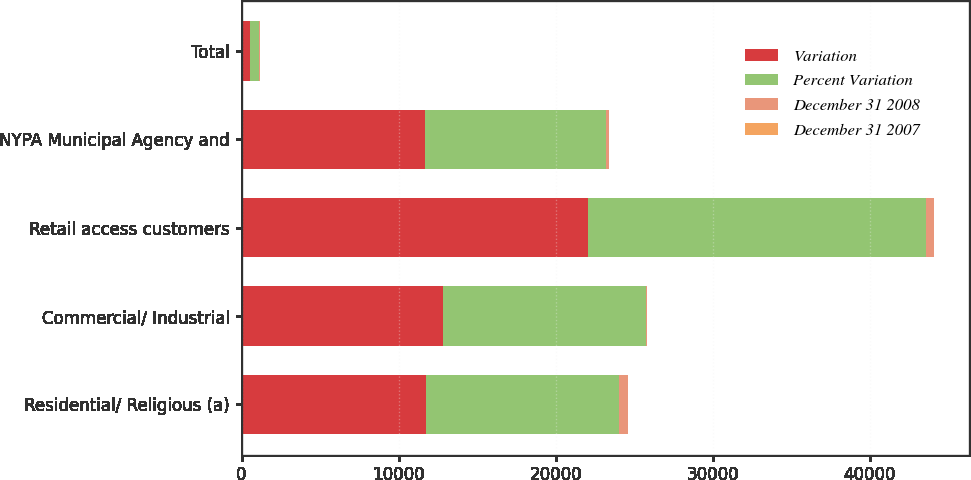Convert chart to OTSL. <chart><loc_0><loc_0><loc_500><loc_500><stacked_bar_chart><ecel><fcel>Residential/ Religious (a)<fcel>Commercial/ Industrial<fcel>Retail access customers<fcel>NYPA Municipal Agency and<fcel>Total<nl><fcel>Variation<fcel>11720<fcel>12852<fcel>22047<fcel>11704<fcel>553.5<nl><fcel>Percent Variation<fcel>12312<fcel>12918<fcel>21532<fcel>11499<fcel>553.5<nl><fcel>December 31 2008<fcel>592<fcel>66<fcel>515<fcel>205<fcel>62<nl><fcel>December 31 2007<fcel>4.8<fcel>0.5<fcel>2.4<fcel>1.8<fcel>0.1<nl></chart> 